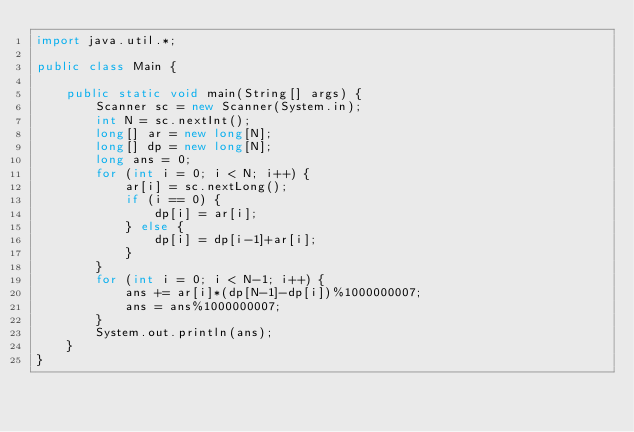Convert code to text. <code><loc_0><loc_0><loc_500><loc_500><_Java_>import java.util.*;

public class Main {

    public static void main(String[] args) {
        Scanner sc = new Scanner(System.in);
        int N = sc.nextInt();
        long[] ar = new long[N];
        long[] dp = new long[N];
        long ans = 0;
        for (int i = 0; i < N; i++) {
            ar[i] = sc.nextLong();
            if (i == 0) {
                dp[i] = ar[i];
            } else {
                dp[i] = dp[i-1]+ar[i];
            }            
        }
        for (int i = 0; i < N-1; i++) {
            ans += ar[i]*(dp[N-1]-dp[i])%1000000007;
            ans = ans%1000000007;
        }
        System.out.println(ans);
    }
}
</code> 